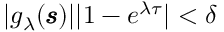Convert formula to latex. <formula><loc_0><loc_0><loc_500><loc_500>\begin{array} { r } { | g _ { \lambda } ( \pm b { \ m a t h s c r { s } } ) | | 1 - e ^ { \lambda \tau } | < \delta } \end{array}</formula> 